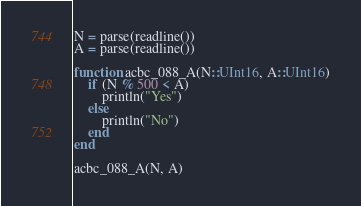Convert code to text. <code><loc_0><loc_0><loc_500><loc_500><_Julia_>N = parse(readline())
A = parse(readline())

function acbc_088_A(N::UInt16, A::UInt16)
    if (N % 500 < A)
        println("Yes")
    else
        println("No")
    end
end

acbc_088_A(N, A)</code> 